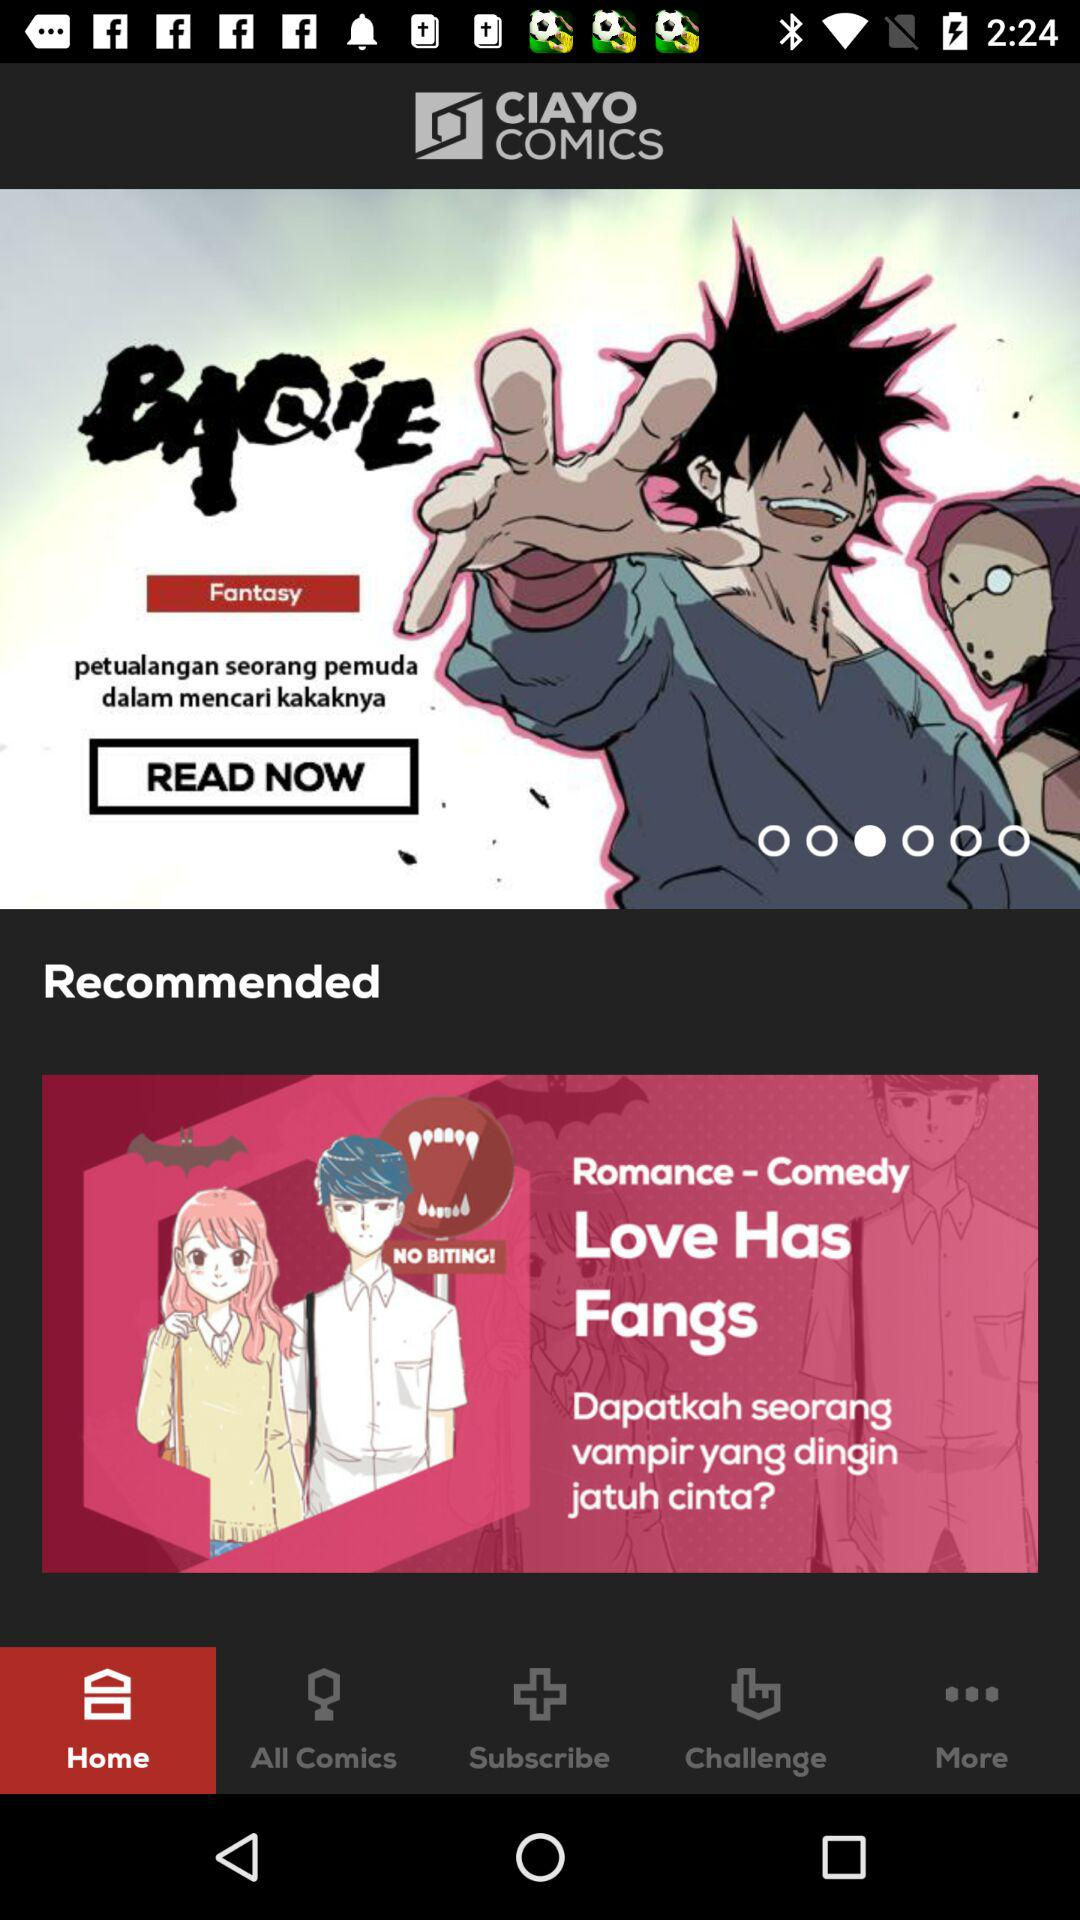Which tab is selected? The selected tab is "Home". 